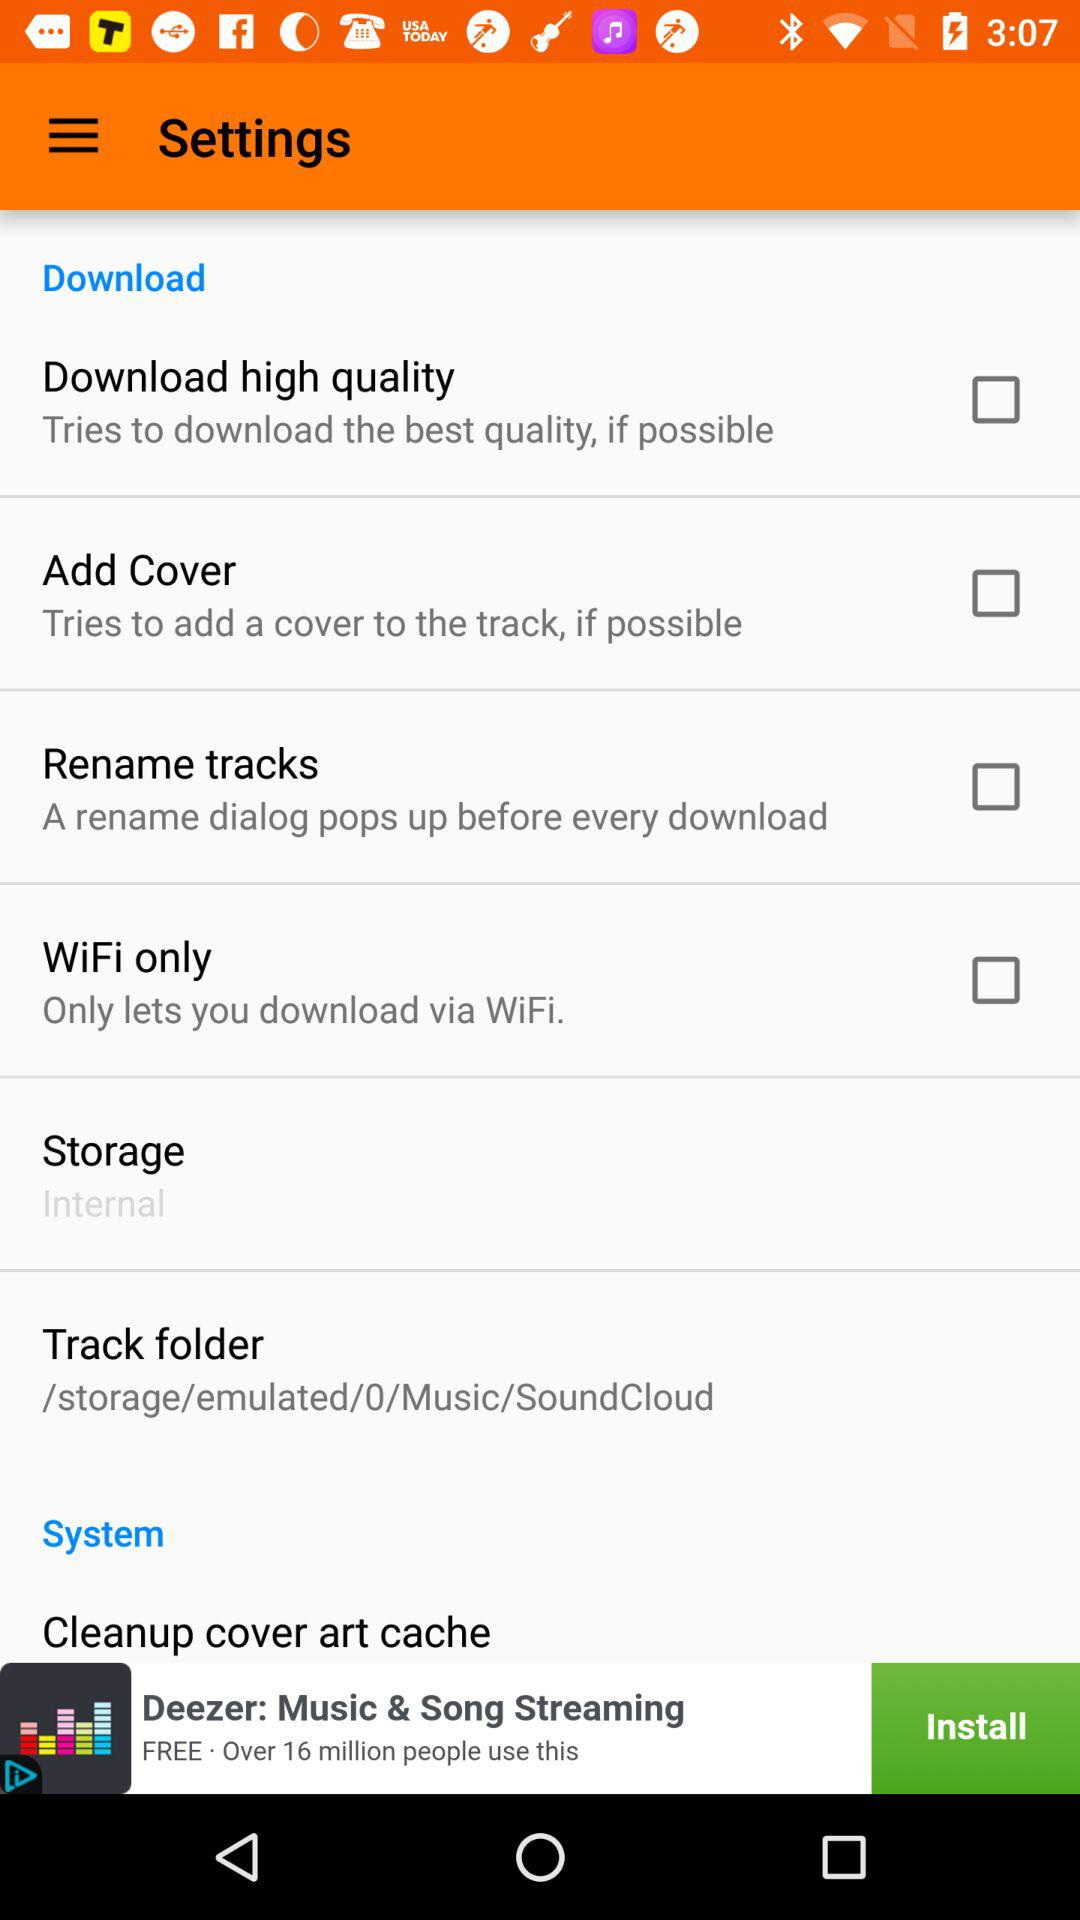What is the status of "WiFi only"? The status of "WiFi only" is off. 